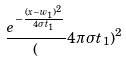<formula> <loc_0><loc_0><loc_500><loc_500>\frac { e ^ { - \frac { ( x - w _ { 1 } ) ^ { 2 } } { 4 \sigma t _ { 1 } } } } ( 4 \pi \sigma t _ { 1 } ) ^ { 2 }</formula> 